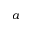<formula> <loc_0><loc_0><loc_500><loc_500>a</formula> 